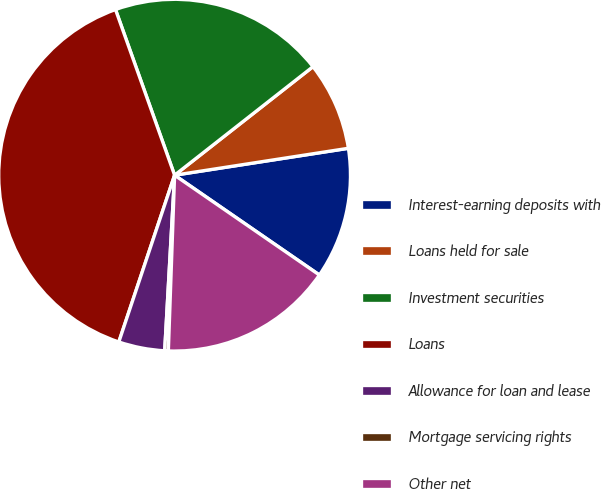Convert chart. <chart><loc_0><loc_0><loc_500><loc_500><pie_chart><fcel>Interest-earning deposits with<fcel>Loans held for sale<fcel>Investment securities<fcel>Loans<fcel>Allowance for loan and lease<fcel>Mortgage servicing rights<fcel>Other net<nl><fcel>12.05%<fcel>8.14%<fcel>19.87%<fcel>39.41%<fcel>4.24%<fcel>0.33%<fcel>15.96%<nl></chart> 